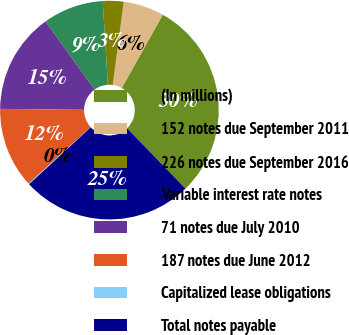Convert chart. <chart><loc_0><loc_0><loc_500><loc_500><pie_chart><fcel>(In millions)<fcel>152 notes due September 2011<fcel>226 notes due September 2016<fcel>Variable interest rate notes<fcel>71 notes due July 2010<fcel>187 notes due June 2012<fcel>Capitalized lease obligations<fcel>Total notes payable<nl><fcel>29.63%<fcel>6.02%<fcel>3.07%<fcel>8.97%<fcel>14.87%<fcel>11.92%<fcel>0.12%<fcel>25.39%<nl></chart> 